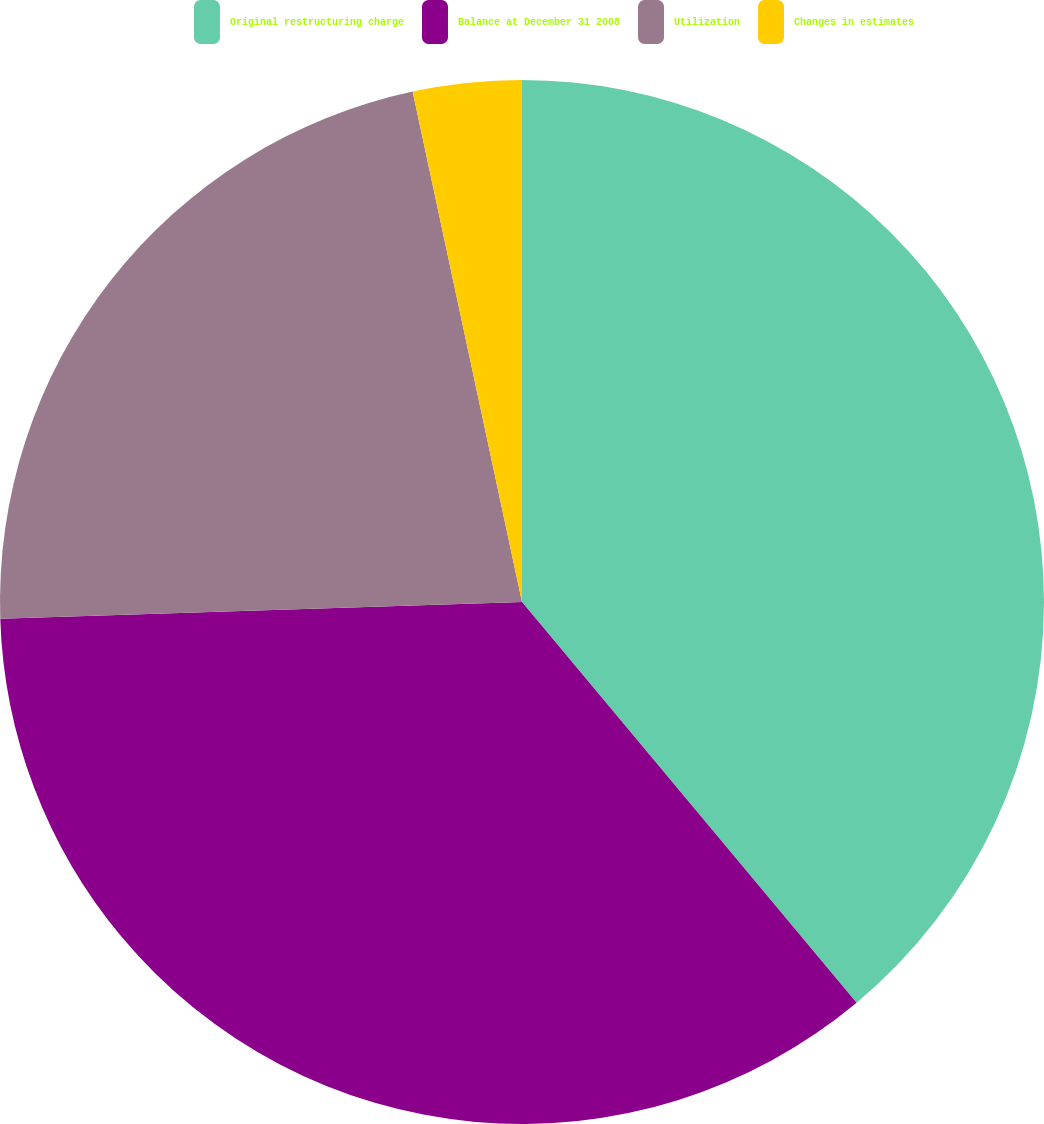<chart> <loc_0><loc_0><loc_500><loc_500><pie_chart><fcel>Original restructuring charge<fcel>Balance at December 31 2008<fcel>Utilization<fcel>Changes in estimates<nl><fcel>38.93%<fcel>35.57%<fcel>22.15%<fcel>3.36%<nl></chart> 